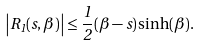<formula> <loc_0><loc_0><loc_500><loc_500>\left | R _ { 1 } ( s , \beta ) \right | \leq \frac { 1 } { 2 } ( \beta - s ) \sinh ( \beta ) .</formula> 